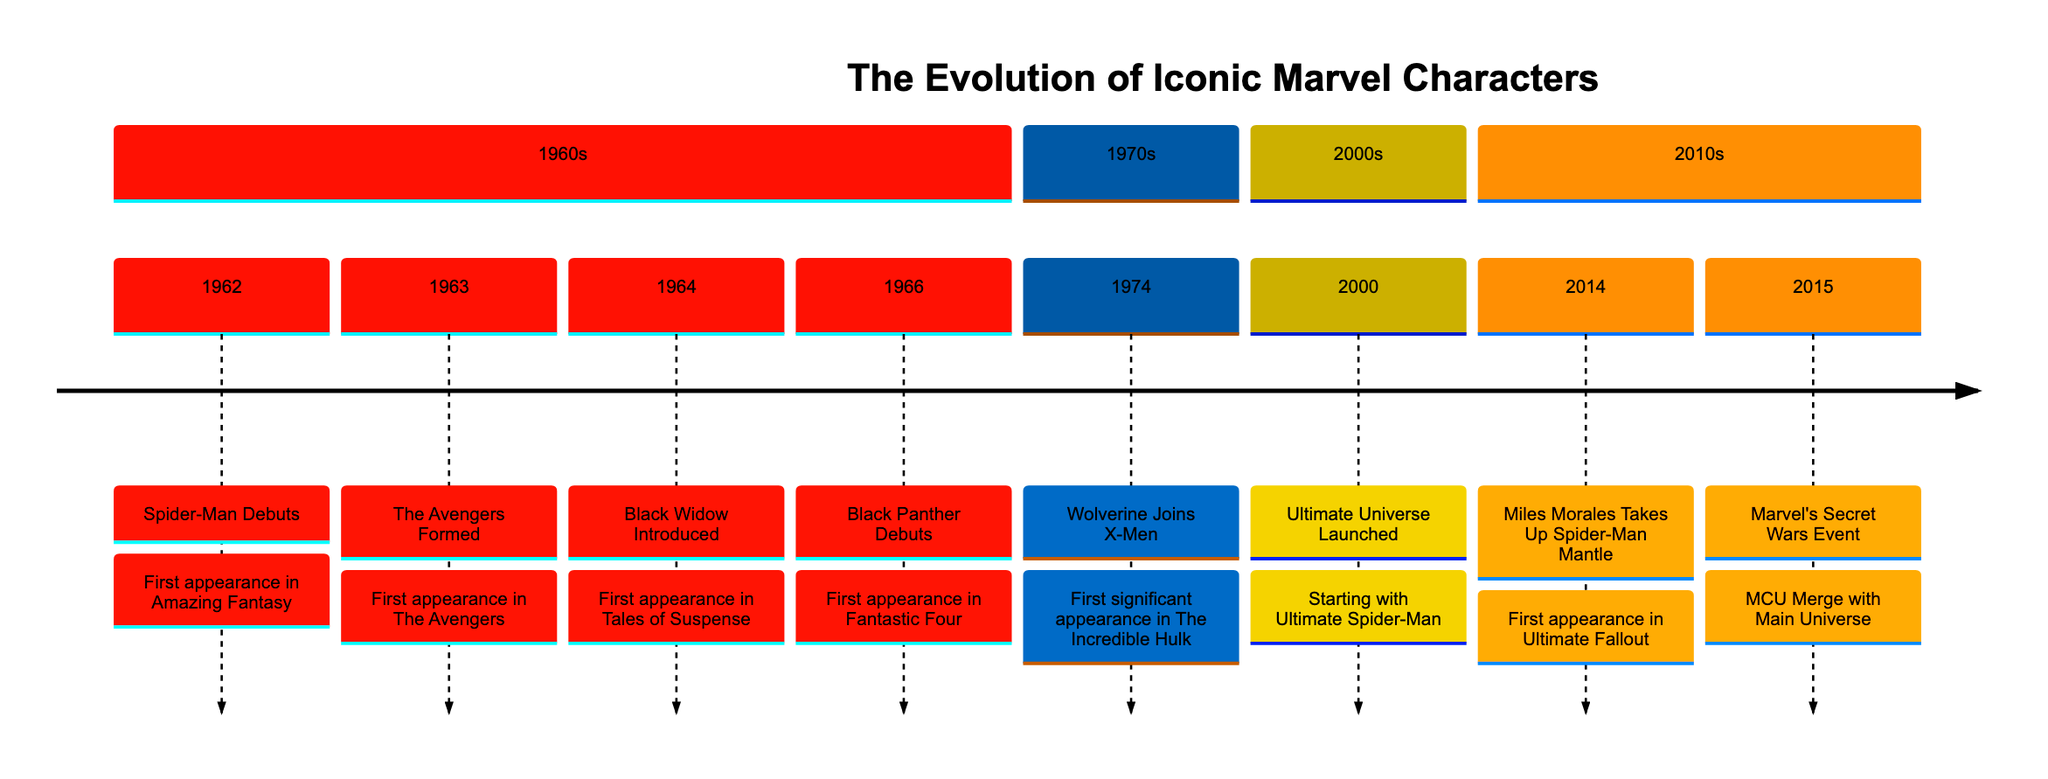What year did Spider-Man debut? The timeline indicates that Spider-Man first appeared in Amazing Fantasy #15 in the year 1962.
Answer: 1962 Which character was introduced in 1964? According to the timeline, the character Black Widow was introduced in 1964 with her first appearance in Tales of Suspense #52.
Answer: Black Widow How many characters debuted in the 1960s? By analyzing the timeline section for the 1960s, there are four characters listed: Spider-Man, The Avengers, Black Widow, and Black Panther. Thus, the count is four.
Answer: 4 In what year was Wolverine’s significant appearance? The timeline states that Wolverine made his first significant appearance in The Incredible Hulk #181, which occurred in 1974.
Answer: 1974 What major event occurred in 2015? The timeline indicates that in 2015 the event Marvel's Secret Wars Event took place, marking a merge between the MCU and the Main Universe.
Answer: Marvel's Secret Wars Event Which character took up the Spider-Man mantle in 2014? The timeline shows that Miles Morales took up the Spider-Man mantle in 2014, marking a significant development in the Spider-Man narrative.
Answer: Miles Morales When did the Ultimate Universe launch? Referring to the timeline, the Ultimate Universe launched in the year 2000, starting with Ultimate Spider-Man #1.
Answer: 2000 How many sections are displayed in the timeline? The timeline is divided into four sections: the 1960s, 1970s, 2000s, and 2010s. Thus, there are four sections total.
Answer: 4 What was the first appearance of Black Panther? The timeline indicates that Black Panther made his first appearance in Fantastic Four #52, dating back to 1966.
Answer: Fantastic Four #52 